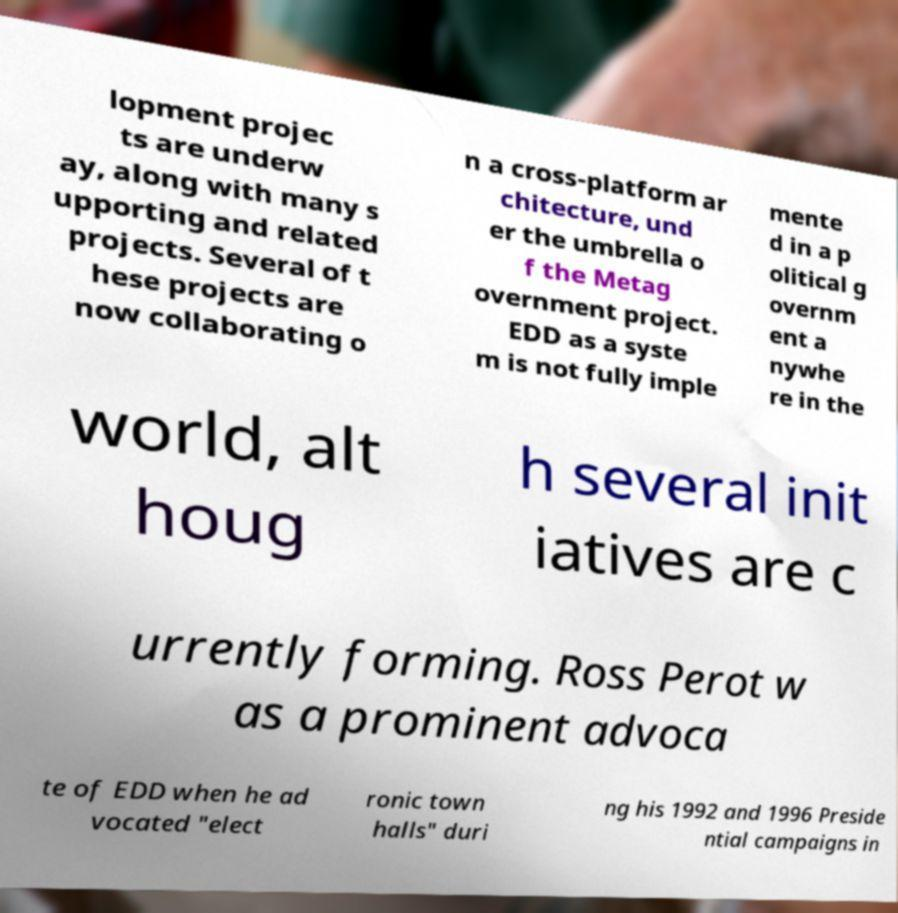Could you assist in decoding the text presented in this image and type it out clearly? lopment projec ts are underw ay, along with many s upporting and related projects. Several of t hese projects are now collaborating o n a cross-platform ar chitecture, und er the umbrella o f the Metag overnment project. EDD as a syste m is not fully imple mente d in a p olitical g overnm ent a nywhe re in the world, alt houg h several init iatives are c urrently forming. Ross Perot w as a prominent advoca te of EDD when he ad vocated "elect ronic town halls" duri ng his 1992 and 1996 Preside ntial campaigns in 